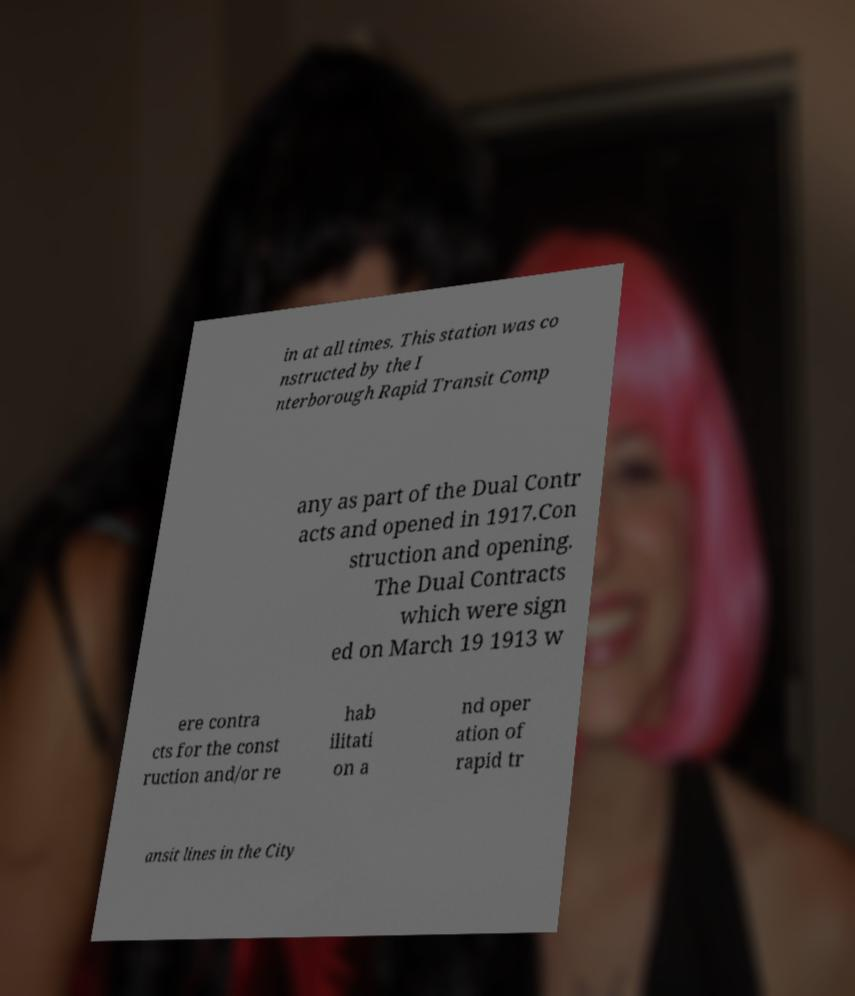Could you extract and type out the text from this image? in at all times. This station was co nstructed by the I nterborough Rapid Transit Comp any as part of the Dual Contr acts and opened in 1917.Con struction and opening. The Dual Contracts which were sign ed on March 19 1913 w ere contra cts for the const ruction and/or re hab ilitati on a nd oper ation of rapid tr ansit lines in the City 